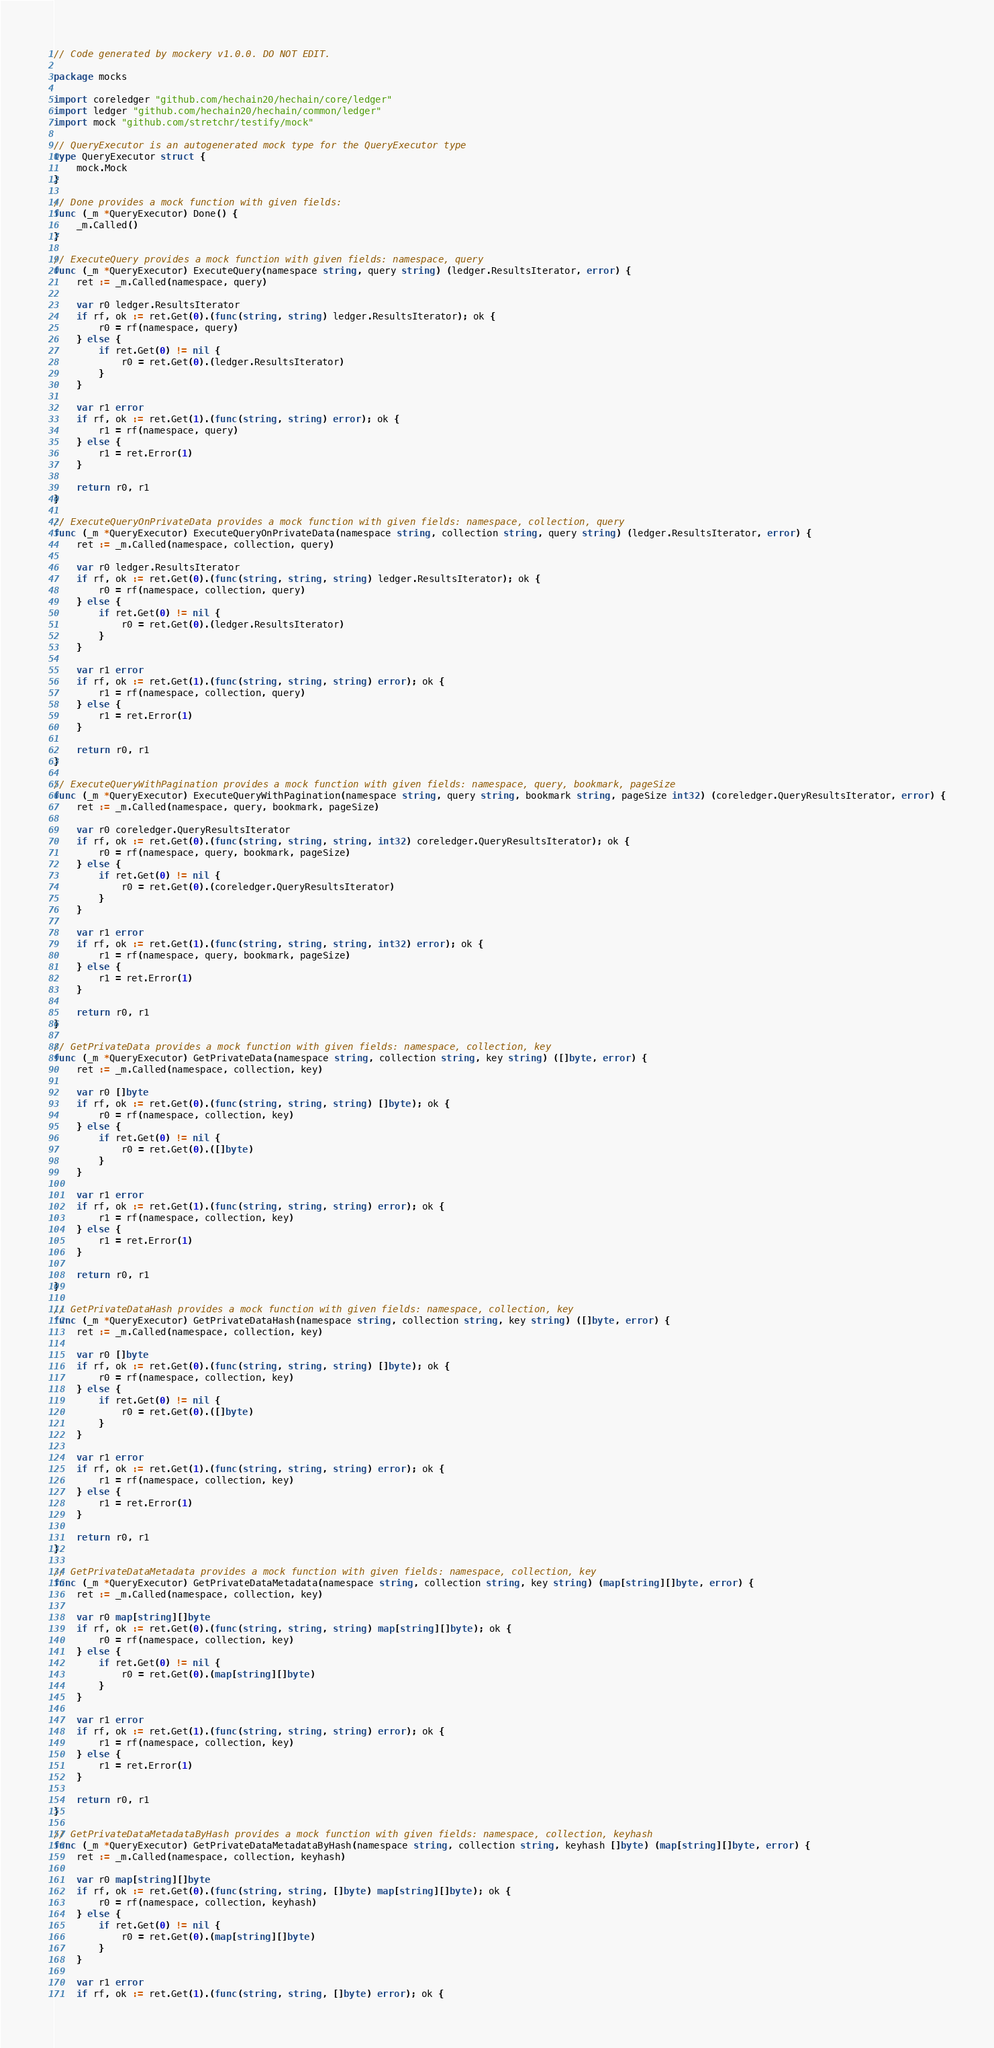Convert code to text. <code><loc_0><loc_0><loc_500><loc_500><_Go_>// Code generated by mockery v1.0.0. DO NOT EDIT.

package mocks

import coreledger "github.com/hechain20/hechain/core/ledger"
import ledger "github.com/hechain20/hechain/common/ledger"
import mock "github.com/stretchr/testify/mock"

// QueryExecutor is an autogenerated mock type for the QueryExecutor type
type QueryExecutor struct {
	mock.Mock
}

// Done provides a mock function with given fields:
func (_m *QueryExecutor) Done() {
	_m.Called()
}

// ExecuteQuery provides a mock function with given fields: namespace, query
func (_m *QueryExecutor) ExecuteQuery(namespace string, query string) (ledger.ResultsIterator, error) {
	ret := _m.Called(namespace, query)

	var r0 ledger.ResultsIterator
	if rf, ok := ret.Get(0).(func(string, string) ledger.ResultsIterator); ok {
		r0 = rf(namespace, query)
	} else {
		if ret.Get(0) != nil {
			r0 = ret.Get(0).(ledger.ResultsIterator)
		}
	}

	var r1 error
	if rf, ok := ret.Get(1).(func(string, string) error); ok {
		r1 = rf(namespace, query)
	} else {
		r1 = ret.Error(1)
	}

	return r0, r1
}

// ExecuteQueryOnPrivateData provides a mock function with given fields: namespace, collection, query
func (_m *QueryExecutor) ExecuteQueryOnPrivateData(namespace string, collection string, query string) (ledger.ResultsIterator, error) {
	ret := _m.Called(namespace, collection, query)

	var r0 ledger.ResultsIterator
	if rf, ok := ret.Get(0).(func(string, string, string) ledger.ResultsIterator); ok {
		r0 = rf(namespace, collection, query)
	} else {
		if ret.Get(0) != nil {
			r0 = ret.Get(0).(ledger.ResultsIterator)
		}
	}

	var r1 error
	if rf, ok := ret.Get(1).(func(string, string, string) error); ok {
		r1 = rf(namespace, collection, query)
	} else {
		r1 = ret.Error(1)
	}

	return r0, r1
}

// ExecuteQueryWithPagination provides a mock function with given fields: namespace, query, bookmark, pageSize
func (_m *QueryExecutor) ExecuteQueryWithPagination(namespace string, query string, bookmark string, pageSize int32) (coreledger.QueryResultsIterator, error) {
	ret := _m.Called(namespace, query, bookmark, pageSize)

	var r0 coreledger.QueryResultsIterator
	if rf, ok := ret.Get(0).(func(string, string, string, int32) coreledger.QueryResultsIterator); ok {
		r0 = rf(namespace, query, bookmark, pageSize)
	} else {
		if ret.Get(0) != nil {
			r0 = ret.Get(0).(coreledger.QueryResultsIterator)
		}
	}

	var r1 error
	if rf, ok := ret.Get(1).(func(string, string, string, int32) error); ok {
		r1 = rf(namespace, query, bookmark, pageSize)
	} else {
		r1 = ret.Error(1)
	}

	return r0, r1
}

// GetPrivateData provides a mock function with given fields: namespace, collection, key
func (_m *QueryExecutor) GetPrivateData(namespace string, collection string, key string) ([]byte, error) {
	ret := _m.Called(namespace, collection, key)

	var r0 []byte
	if rf, ok := ret.Get(0).(func(string, string, string) []byte); ok {
		r0 = rf(namespace, collection, key)
	} else {
		if ret.Get(0) != nil {
			r0 = ret.Get(0).([]byte)
		}
	}

	var r1 error
	if rf, ok := ret.Get(1).(func(string, string, string) error); ok {
		r1 = rf(namespace, collection, key)
	} else {
		r1 = ret.Error(1)
	}

	return r0, r1
}

// GetPrivateDataHash provides a mock function with given fields: namespace, collection, key
func (_m *QueryExecutor) GetPrivateDataHash(namespace string, collection string, key string) ([]byte, error) {
	ret := _m.Called(namespace, collection, key)

	var r0 []byte
	if rf, ok := ret.Get(0).(func(string, string, string) []byte); ok {
		r0 = rf(namespace, collection, key)
	} else {
		if ret.Get(0) != nil {
			r0 = ret.Get(0).([]byte)
		}
	}

	var r1 error
	if rf, ok := ret.Get(1).(func(string, string, string) error); ok {
		r1 = rf(namespace, collection, key)
	} else {
		r1 = ret.Error(1)
	}

	return r0, r1
}

// GetPrivateDataMetadata provides a mock function with given fields: namespace, collection, key
func (_m *QueryExecutor) GetPrivateDataMetadata(namespace string, collection string, key string) (map[string][]byte, error) {
	ret := _m.Called(namespace, collection, key)

	var r0 map[string][]byte
	if rf, ok := ret.Get(0).(func(string, string, string) map[string][]byte); ok {
		r0 = rf(namespace, collection, key)
	} else {
		if ret.Get(0) != nil {
			r0 = ret.Get(0).(map[string][]byte)
		}
	}

	var r1 error
	if rf, ok := ret.Get(1).(func(string, string, string) error); ok {
		r1 = rf(namespace, collection, key)
	} else {
		r1 = ret.Error(1)
	}

	return r0, r1
}

// GetPrivateDataMetadataByHash provides a mock function with given fields: namespace, collection, keyhash
func (_m *QueryExecutor) GetPrivateDataMetadataByHash(namespace string, collection string, keyhash []byte) (map[string][]byte, error) {
	ret := _m.Called(namespace, collection, keyhash)

	var r0 map[string][]byte
	if rf, ok := ret.Get(0).(func(string, string, []byte) map[string][]byte); ok {
		r0 = rf(namespace, collection, keyhash)
	} else {
		if ret.Get(0) != nil {
			r0 = ret.Get(0).(map[string][]byte)
		}
	}

	var r1 error
	if rf, ok := ret.Get(1).(func(string, string, []byte) error); ok {</code> 